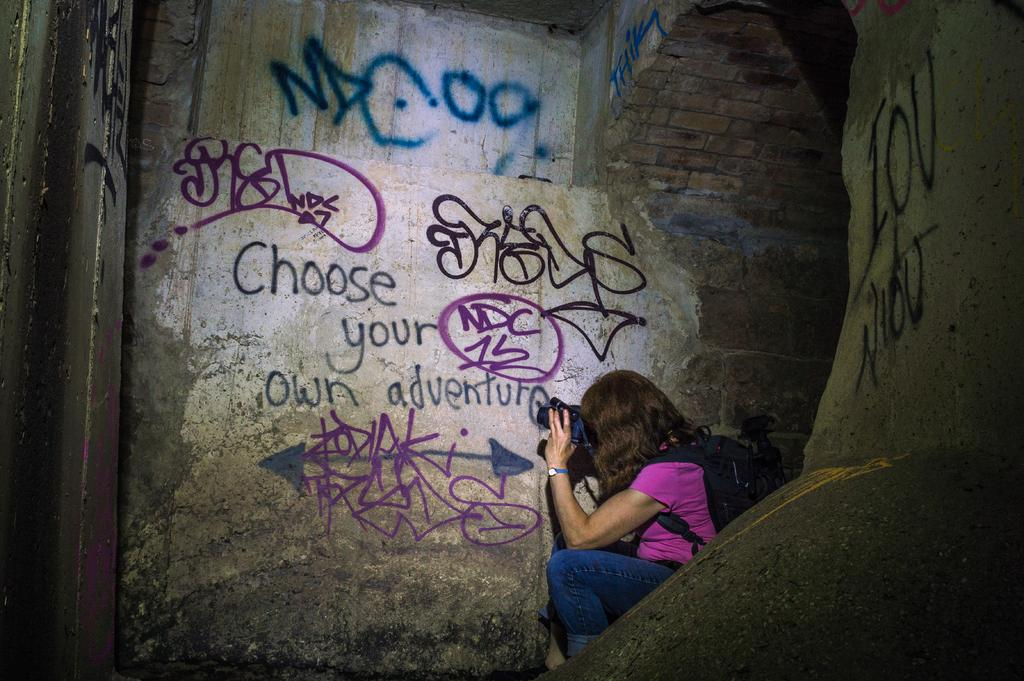Who is the main subject in the image? There is a lady in the image. What is the lady wearing on her back? The lady is wearing a backpack. What is the lady holding in her hand? The lady is holding an object in her hand. What can be seen on the walls in the image? There is text on the walls in the image. Reasoning: Let'g: Let's think step by step in order to produce the conversation. We start by identifying the main subject in the image, which is the lady. Then, we describe the lady's attire and accessories, specifically mentioning the backpack she is wearing. Next, we focus on the object the lady is holding in her hand. Finally, we mention the text on the walls, which adds context to the image. Absurd Question/Answer: What type of baseball can be seen in the lady's hand in the image? There is no baseball present in the image; the lady is holding an unspecified object. Can you tell me how many carts are visible in the image? There are no carts present in the image. What is the main subject in the image? There is a car in the image. Where is the car located? The car is parked on the street. What can be seen on both sides of the street? There are trees on both sides of the street. What is visible in the background of the image? The sky is visible in the image. Reasoning: Let's think step by step in order to produce the conversation. We start by identifying the main subject in the image, which is the car. Then, we describe the car's location, specifically mentioning that it is parked on the street. Next, we focus on the surrounding environment, noting the presence of trees on both sides of the street. Finally, we mention the sky, which is visible in the background. Absurd Question/Answer: Can you tell me how many parrots are sitting on the car in the image? There are no parrots present in the image; the car is parked on the street with no animals visible. 